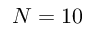Convert formula to latex. <formula><loc_0><loc_0><loc_500><loc_500>N = 1 0</formula> 